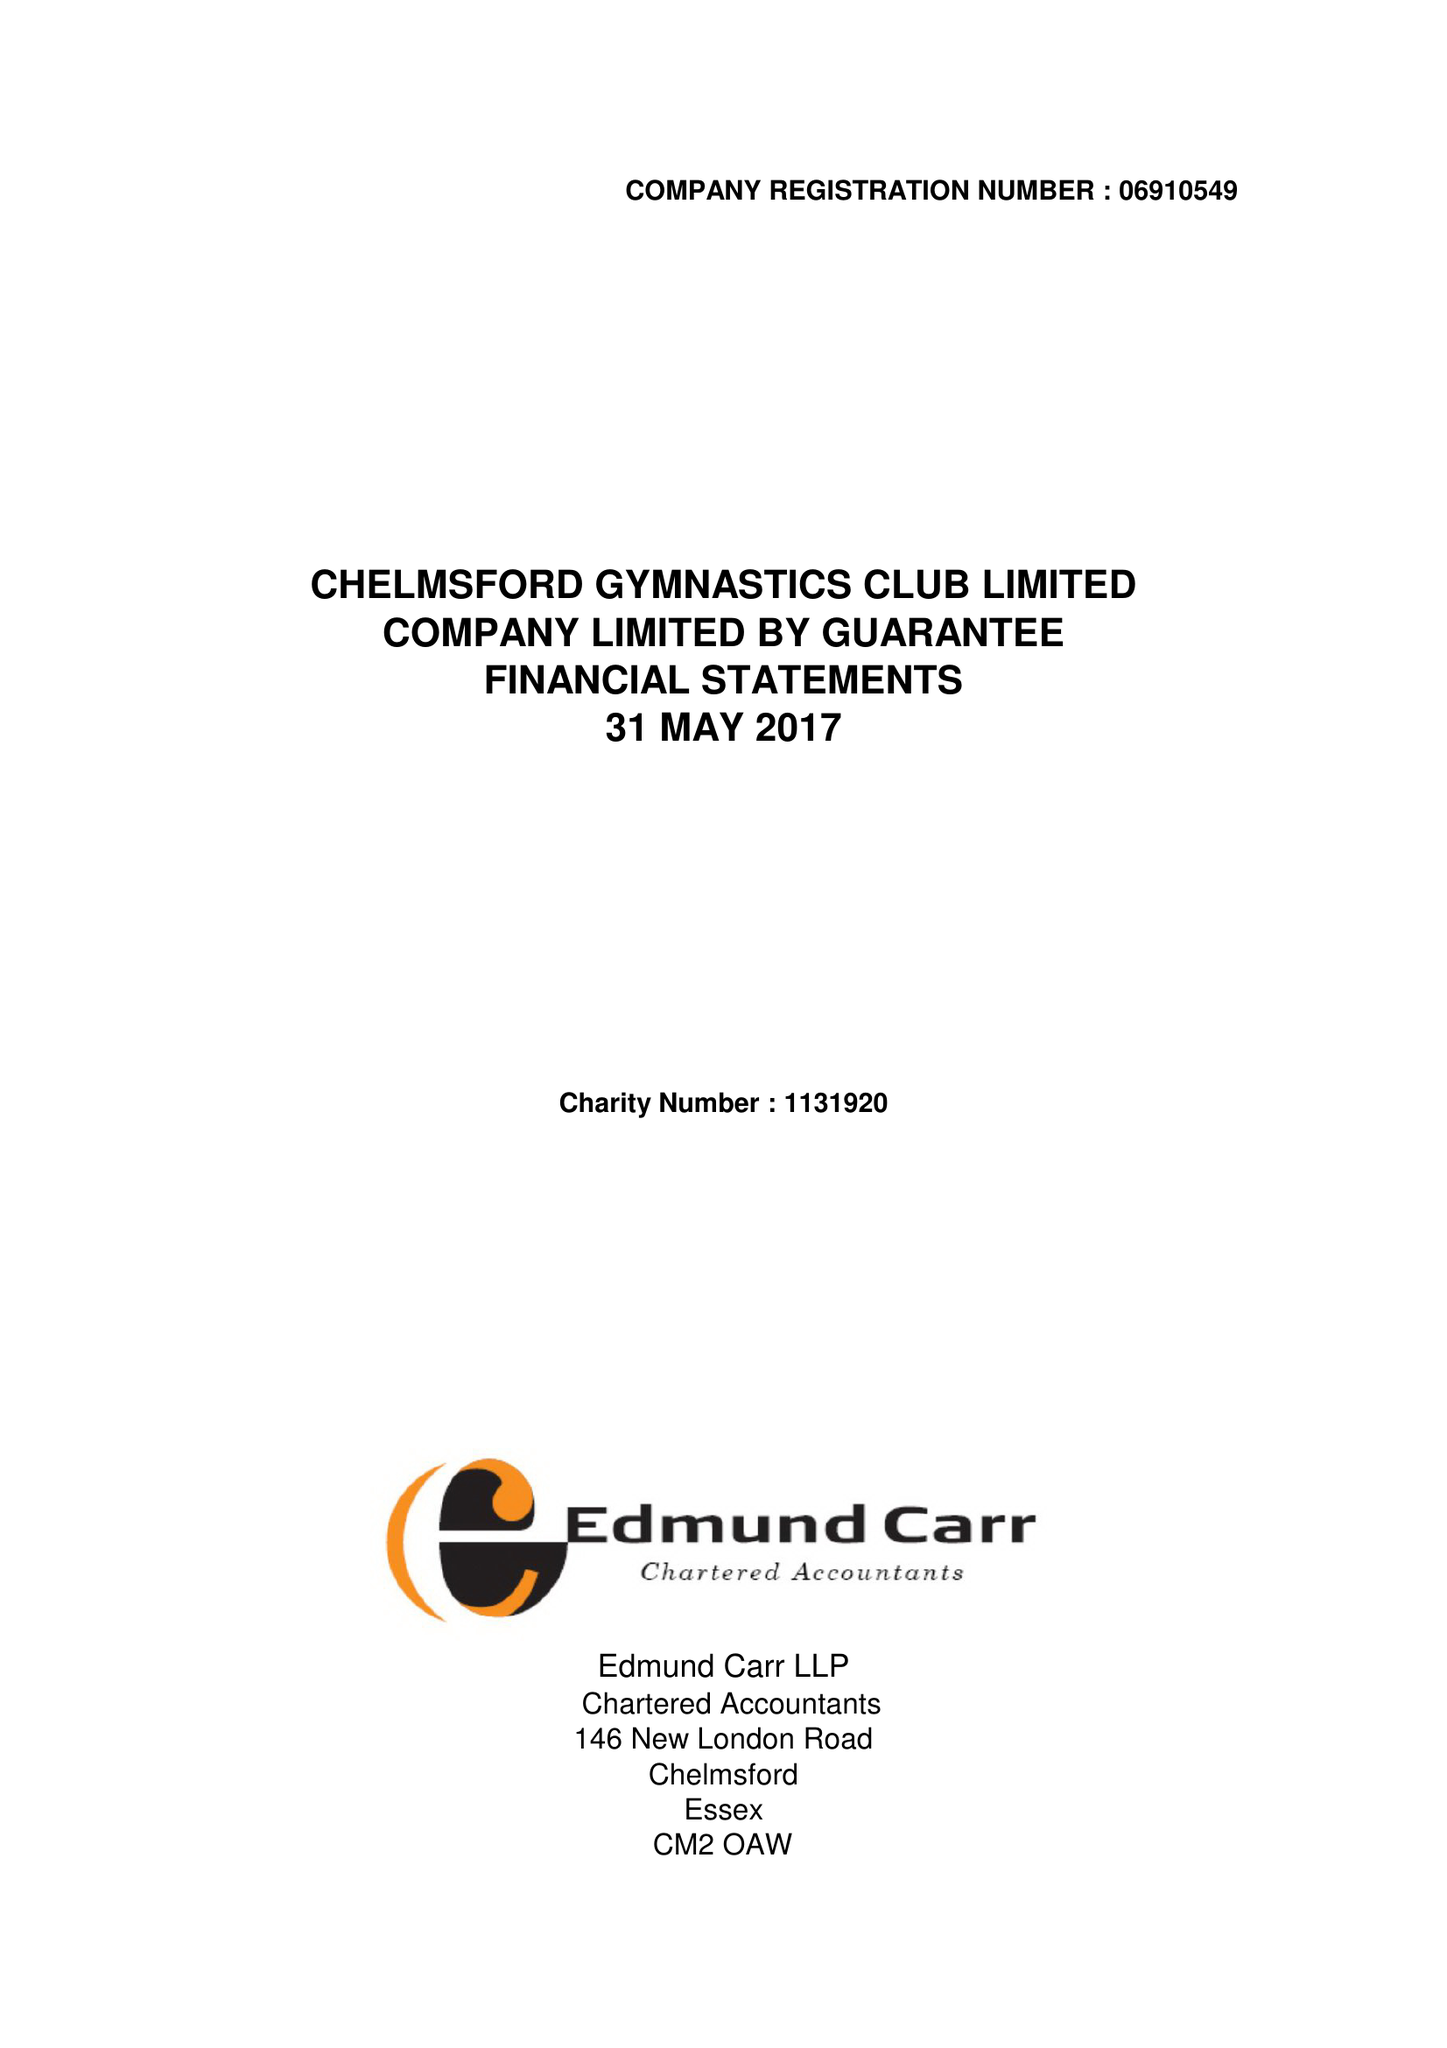What is the value for the charity_number?
Answer the question using a single word or phrase. 1131920 